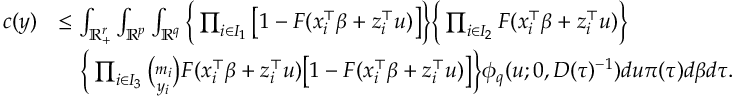Convert formula to latex. <formula><loc_0><loc_0><loc_500><loc_500>\begin{array} { r l } { c ( y ) } & { \leq \int _ { \mathbb { R } _ { + } ^ { r } } \int _ { \mathbb { R } ^ { p } } \int _ { \mathbb { R } ^ { q } } \left \{ \prod _ { i \in I _ { 1 } } \left [ 1 - F ( x _ { i } ^ { \top } \beta + z _ { i } ^ { \top } u ) \right ] \right \} \left \{ \prod _ { i \in I _ { 2 } } F ( x _ { i } ^ { \top } \beta + z _ { i } ^ { \top } u ) \right \} } \\ & { \quad \left \{ \prod _ { i \in I _ { 3 } } { \binom { m _ { i } } { y _ { i } } } F ( x _ { i } ^ { \top } \beta + z _ { i } ^ { \top } u ) \left [ 1 - F ( x _ { i } ^ { \top } \beta + z _ { i } ^ { \top } u ) \right ] \right \} \phi _ { q } ( u ; 0 , D ( \tau ) ^ { - 1 } ) d u \pi ( \tau ) d \beta d \tau . } \end{array}</formula> 